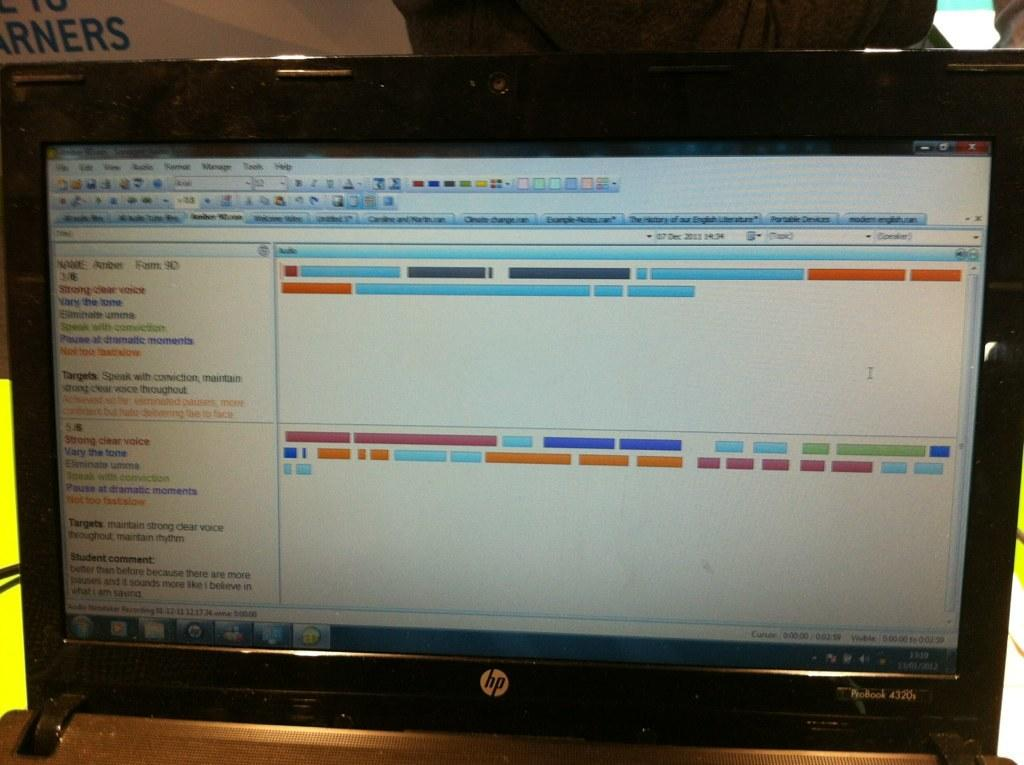<image>
Describe the image concisely. A computer screen is open to a page that has information about someone named Amber. 